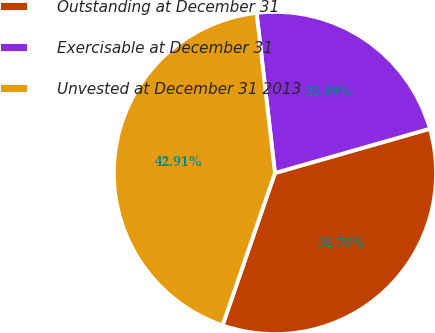Convert chart to OTSL. <chart><loc_0><loc_0><loc_500><loc_500><pie_chart><fcel>Outstanding at December 31<fcel>Exercisable at December 31<fcel>Unvested at December 31 2013<nl><fcel>34.7%<fcel>22.39%<fcel>42.91%<nl></chart> 